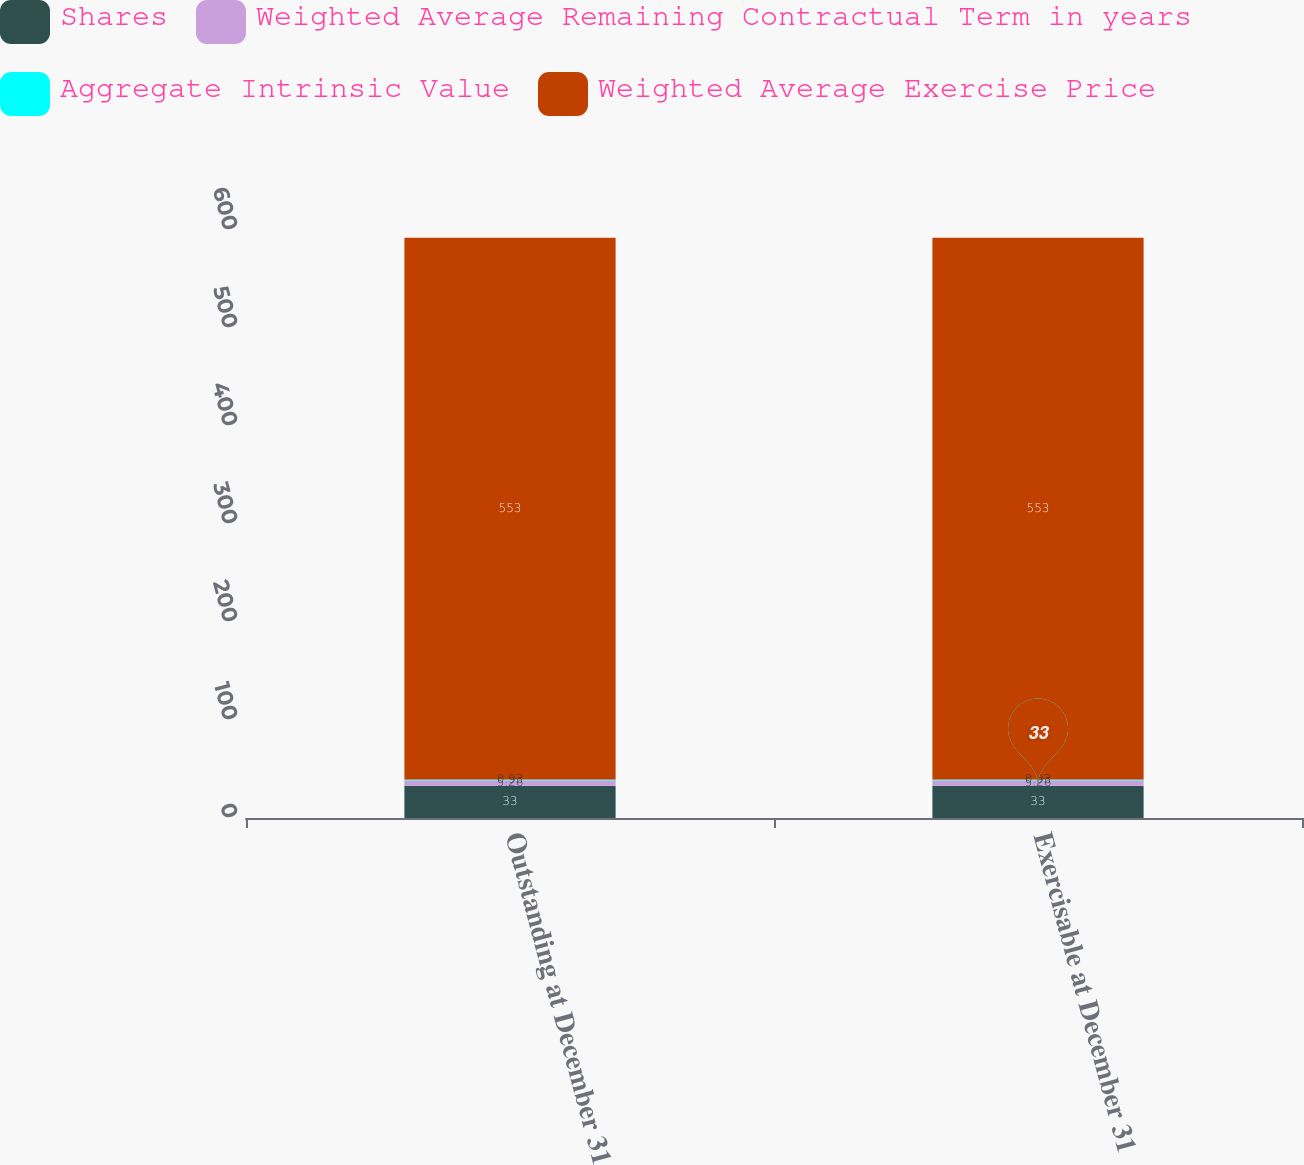Convert chart to OTSL. <chart><loc_0><loc_0><loc_500><loc_500><stacked_bar_chart><ecel><fcel>Outstanding at December 31<fcel>Exercisable at December 31<nl><fcel>Shares<fcel>33<fcel>33<nl><fcel>Weighted Average Remaining Contractual Term in years<fcel>5.26<fcel>5.26<nl><fcel>Aggregate Intrinsic Value<fcel>0.93<fcel>0.93<nl><fcel>Weighted Average Exercise Price<fcel>553<fcel>553<nl></chart> 